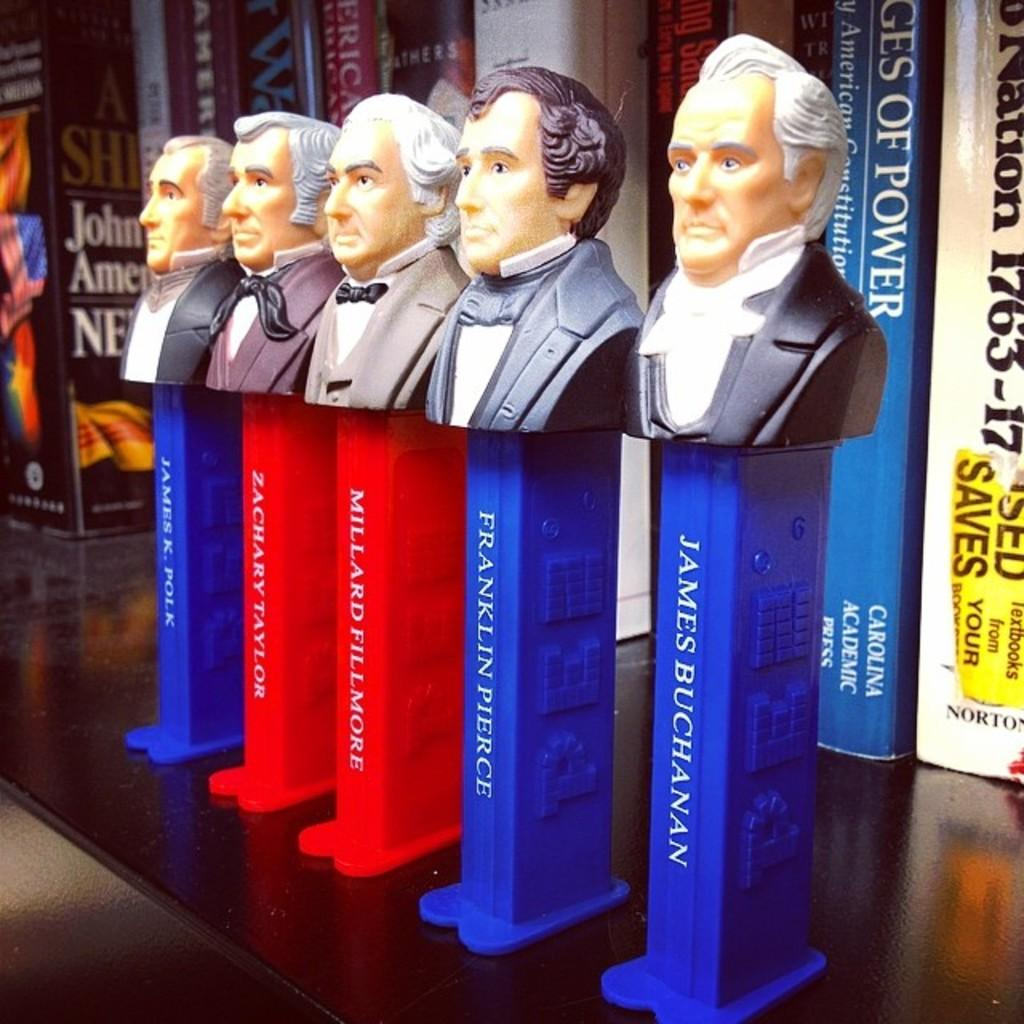<image>
Share a concise interpretation of the image provided. A row of pez dispensers of US presidents with James Buchanan on the right. 